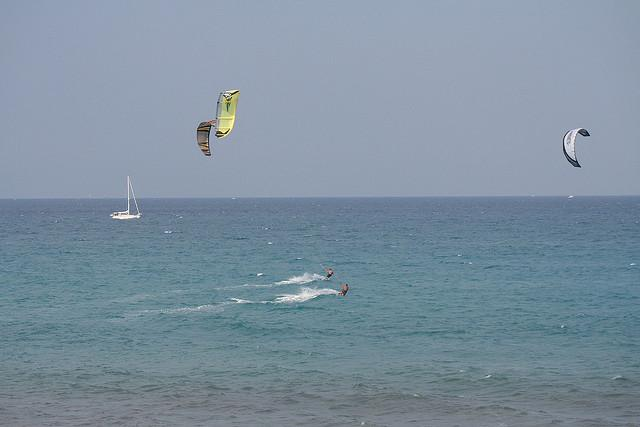What sport are the two people in the water participating in?

Choices:
A) surfing
B) sailing
C) swimming
D) para waterskiing para waterskiing 